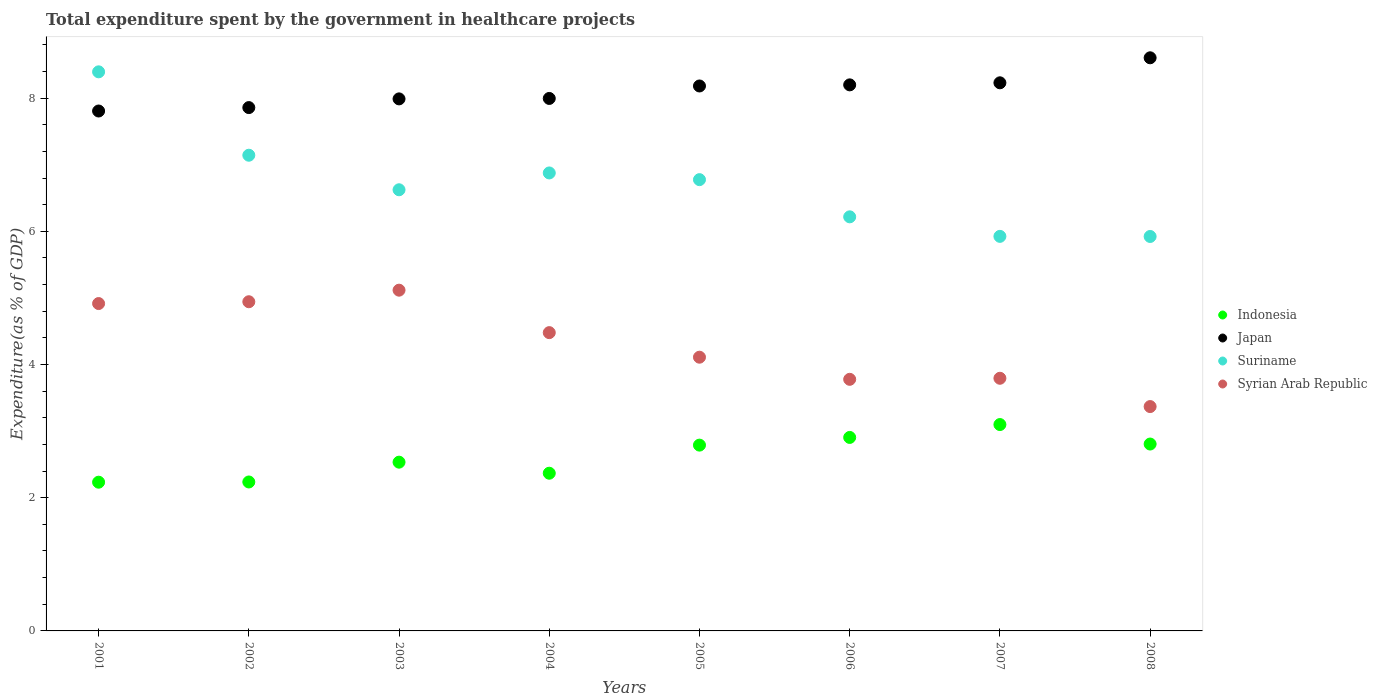What is the total expenditure spent by the government in healthcare projects in Syrian Arab Republic in 2007?
Your response must be concise. 3.79. Across all years, what is the maximum total expenditure spent by the government in healthcare projects in Suriname?
Your response must be concise. 8.39. Across all years, what is the minimum total expenditure spent by the government in healthcare projects in Suriname?
Provide a short and direct response. 5.92. In which year was the total expenditure spent by the government in healthcare projects in Syrian Arab Republic minimum?
Your answer should be compact. 2008. What is the total total expenditure spent by the government in healthcare projects in Syrian Arab Republic in the graph?
Offer a very short reply. 34.5. What is the difference between the total expenditure spent by the government in healthcare projects in Japan in 2001 and that in 2005?
Give a very brief answer. -0.38. What is the difference between the total expenditure spent by the government in healthcare projects in Indonesia in 2002 and the total expenditure spent by the government in healthcare projects in Japan in 2007?
Your response must be concise. -5.99. What is the average total expenditure spent by the government in healthcare projects in Suriname per year?
Offer a very short reply. 6.73. In the year 2004, what is the difference between the total expenditure spent by the government in healthcare projects in Syrian Arab Republic and total expenditure spent by the government in healthcare projects in Suriname?
Give a very brief answer. -2.4. In how many years, is the total expenditure spent by the government in healthcare projects in Indonesia greater than 5.6 %?
Your answer should be very brief. 0. What is the ratio of the total expenditure spent by the government in healthcare projects in Suriname in 2004 to that in 2007?
Keep it short and to the point. 1.16. What is the difference between the highest and the second highest total expenditure spent by the government in healthcare projects in Suriname?
Provide a succinct answer. 1.25. What is the difference between the highest and the lowest total expenditure spent by the government in healthcare projects in Japan?
Ensure brevity in your answer.  0.8. Is it the case that in every year, the sum of the total expenditure spent by the government in healthcare projects in Japan and total expenditure spent by the government in healthcare projects in Indonesia  is greater than the total expenditure spent by the government in healthcare projects in Suriname?
Offer a very short reply. Yes. Does the total expenditure spent by the government in healthcare projects in Syrian Arab Republic monotonically increase over the years?
Provide a succinct answer. No. How many years are there in the graph?
Offer a terse response. 8. Are the values on the major ticks of Y-axis written in scientific E-notation?
Make the answer very short. No. Does the graph contain grids?
Offer a terse response. No. Where does the legend appear in the graph?
Your answer should be very brief. Center right. How are the legend labels stacked?
Offer a terse response. Vertical. What is the title of the graph?
Your response must be concise. Total expenditure spent by the government in healthcare projects. Does "Kosovo" appear as one of the legend labels in the graph?
Offer a terse response. No. What is the label or title of the Y-axis?
Give a very brief answer. Expenditure(as % of GDP). What is the Expenditure(as % of GDP) of Indonesia in 2001?
Keep it short and to the point. 2.23. What is the Expenditure(as % of GDP) in Japan in 2001?
Offer a terse response. 7.81. What is the Expenditure(as % of GDP) in Suriname in 2001?
Offer a very short reply. 8.39. What is the Expenditure(as % of GDP) in Syrian Arab Republic in 2001?
Your answer should be compact. 4.92. What is the Expenditure(as % of GDP) in Indonesia in 2002?
Your response must be concise. 2.24. What is the Expenditure(as % of GDP) of Japan in 2002?
Your answer should be very brief. 7.86. What is the Expenditure(as % of GDP) of Suriname in 2002?
Your answer should be compact. 7.14. What is the Expenditure(as % of GDP) in Syrian Arab Republic in 2002?
Your answer should be compact. 4.94. What is the Expenditure(as % of GDP) in Indonesia in 2003?
Your answer should be compact. 2.53. What is the Expenditure(as % of GDP) of Japan in 2003?
Provide a succinct answer. 7.99. What is the Expenditure(as % of GDP) of Suriname in 2003?
Provide a succinct answer. 6.62. What is the Expenditure(as % of GDP) of Syrian Arab Republic in 2003?
Offer a very short reply. 5.12. What is the Expenditure(as % of GDP) in Indonesia in 2004?
Ensure brevity in your answer.  2.37. What is the Expenditure(as % of GDP) in Japan in 2004?
Give a very brief answer. 7.99. What is the Expenditure(as % of GDP) of Suriname in 2004?
Provide a short and direct response. 6.88. What is the Expenditure(as % of GDP) of Syrian Arab Republic in 2004?
Provide a short and direct response. 4.48. What is the Expenditure(as % of GDP) in Indonesia in 2005?
Ensure brevity in your answer.  2.79. What is the Expenditure(as % of GDP) of Japan in 2005?
Provide a succinct answer. 8.18. What is the Expenditure(as % of GDP) of Suriname in 2005?
Provide a short and direct response. 6.78. What is the Expenditure(as % of GDP) in Syrian Arab Republic in 2005?
Ensure brevity in your answer.  4.11. What is the Expenditure(as % of GDP) in Indonesia in 2006?
Provide a short and direct response. 2.91. What is the Expenditure(as % of GDP) in Japan in 2006?
Give a very brief answer. 8.2. What is the Expenditure(as % of GDP) in Suriname in 2006?
Make the answer very short. 6.22. What is the Expenditure(as % of GDP) in Syrian Arab Republic in 2006?
Make the answer very short. 3.78. What is the Expenditure(as % of GDP) of Indonesia in 2007?
Provide a short and direct response. 3.1. What is the Expenditure(as % of GDP) of Japan in 2007?
Offer a very short reply. 8.23. What is the Expenditure(as % of GDP) of Suriname in 2007?
Your answer should be very brief. 5.92. What is the Expenditure(as % of GDP) of Syrian Arab Republic in 2007?
Provide a short and direct response. 3.79. What is the Expenditure(as % of GDP) of Indonesia in 2008?
Offer a terse response. 2.81. What is the Expenditure(as % of GDP) of Japan in 2008?
Ensure brevity in your answer.  8.61. What is the Expenditure(as % of GDP) of Suriname in 2008?
Provide a succinct answer. 5.92. What is the Expenditure(as % of GDP) in Syrian Arab Republic in 2008?
Provide a short and direct response. 3.37. Across all years, what is the maximum Expenditure(as % of GDP) in Indonesia?
Offer a very short reply. 3.1. Across all years, what is the maximum Expenditure(as % of GDP) of Japan?
Give a very brief answer. 8.61. Across all years, what is the maximum Expenditure(as % of GDP) of Suriname?
Offer a terse response. 8.39. Across all years, what is the maximum Expenditure(as % of GDP) in Syrian Arab Republic?
Give a very brief answer. 5.12. Across all years, what is the minimum Expenditure(as % of GDP) in Indonesia?
Your response must be concise. 2.23. Across all years, what is the minimum Expenditure(as % of GDP) of Japan?
Provide a short and direct response. 7.81. Across all years, what is the minimum Expenditure(as % of GDP) in Suriname?
Make the answer very short. 5.92. Across all years, what is the minimum Expenditure(as % of GDP) of Syrian Arab Republic?
Ensure brevity in your answer.  3.37. What is the total Expenditure(as % of GDP) in Indonesia in the graph?
Offer a very short reply. 20.97. What is the total Expenditure(as % of GDP) in Japan in the graph?
Offer a very short reply. 64.86. What is the total Expenditure(as % of GDP) in Suriname in the graph?
Keep it short and to the point. 53.88. What is the total Expenditure(as % of GDP) of Syrian Arab Republic in the graph?
Your answer should be compact. 34.5. What is the difference between the Expenditure(as % of GDP) in Indonesia in 2001 and that in 2002?
Offer a very short reply. -0. What is the difference between the Expenditure(as % of GDP) in Japan in 2001 and that in 2002?
Give a very brief answer. -0.05. What is the difference between the Expenditure(as % of GDP) in Suriname in 2001 and that in 2002?
Keep it short and to the point. 1.25. What is the difference between the Expenditure(as % of GDP) in Syrian Arab Republic in 2001 and that in 2002?
Offer a terse response. -0.03. What is the difference between the Expenditure(as % of GDP) of Indonesia in 2001 and that in 2003?
Provide a succinct answer. -0.3. What is the difference between the Expenditure(as % of GDP) in Japan in 2001 and that in 2003?
Keep it short and to the point. -0.18. What is the difference between the Expenditure(as % of GDP) in Suriname in 2001 and that in 2003?
Give a very brief answer. 1.77. What is the difference between the Expenditure(as % of GDP) of Syrian Arab Republic in 2001 and that in 2003?
Make the answer very short. -0.2. What is the difference between the Expenditure(as % of GDP) of Indonesia in 2001 and that in 2004?
Provide a succinct answer. -0.13. What is the difference between the Expenditure(as % of GDP) of Japan in 2001 and that in 2004?
Give a very brief answer. -0.19. What is the difference between the Expenditure(as % of GDP) in Suriname in 2001 and that in 2004?
Your answer should be very brief. 1.52. What is the difference between the Expenditure(as % of GDP) of Syrian Arab Republic in 2001 and that in 2004?
Offer a very short reply. 0.44. What is the difference between the Expenditure(as % of GDP) in Indonesia in 2001 and that in 2005?
Your answer should be compact. -0.56. What is the difference between the Expenditure(as % of GDP) of Japan in 2001 and that in 2005?
Keep it short and to the point. -0.38. What is the difference between the Expenditure(as % of GDP) of Suriname in 2001 and that in 2005?
Give a very brief answer. 1.62. What is the difference between the Expenditure(as % of GDP) of Syrian Arab Republic in 2001 and that in 2005?
Make the answer very short. 0.81. What is the difference between the Expenditure(as % of GDP) in Indonesia in 2001 and that in 2006?
Your response must be concise. -0.67. What is the difference between the Expenditure(as % of GDP) of Japan in 2001 and that in 2006?
Make the answer very short. -0.39. What is the difference between the Expenditure(as % of GDP) in Suriname in 2001 and that in 2006?
Provide a succinct answer. 2.18. What is the difference between the Expenditure(as % of GDP) in Syrian Arab Republic in 2001 and that in 2006?
Offer a terse response. 1.14. What is the difference between the Expenditure(as % of GDP) in Indonesia in 2001 and that in 2007?
Make the answer very short. -0.87. What is the difference between the Expenditure(as % of GDP) of Japan in 2001 and that in 2007?
Keep it short and to the point. -0.42. What is the difference between the Expenditure(as % of GDP) in Suriname in 2001 and that in 2007?
Give a very brief answer. 2.47. What is the difference between the Expenditure(as % of GDP) in Syrian Arab Republic in 2001 and that in 2007?
Provide a succinct answer. 1.12. What is the difference between the Expenditure(as % of GDP) of Indonesia in 2001 and that in 2008?
Your answer should be compact. -0.57. What is the difference between the Expenditure(as % of GDP) of Japan in 2001 and that in 2008?
Your answer should be compact. -0.8. What is the difference between the Expenditure(as % of GDP) in Suriname in 2001 and that in 2008?
Your answer should be compact. 2.47. What is the difference between the Expenditure(as % of GDP) of Syrian Arab Republic in 2001 and that in 2008?
Ensure brevity in your answer.  1.55. What is the difference between the Expenditure(as % of GDP) in Indonesia in 2002 and that in 2003?
Give a very brief answer. -0.3. What is the difference between the Expenditure(as % of GDP) in Japan in 2002 and that in 2003?
Provide a succinct answer. -0.13. What is the difference between the Expenditure(as % of GDP) of Suriname in 2002 and that in 2003?
Keep it short and to the point. 0.52. What is the difference between the Expenditure(as % of GDP) in Syrian Arab Republic in 2002 and that in 2003?
Provide a short and direct response. -0.17. What is the difference between the Expenditure(as % of GDP) of Indonesia in 2002 and that in 2004?
Your response must be concise. -0.13. What is the difference between the Expenditure(as % of GDP) of Japan in 2002 and that in 2004?
Make the answer very short. -0.14. What is the difference between the Expenditure(as % of GDP) of Suriname in 2002 and that in 2004?
Your response must be concise. 0.27. What is the difference between the Expenditure(as % of GDP) in Syrian Arab Republic in 2002 and that in 2004?
Provide a short and direct response. 0.46. What is the difference between the Expenditure(as % of GDP) of Indonesia in 2002 and that in 2005?
Provide a short and direct response. -0.55. What is the difference between the Expenditure(as % of GDP) of Japan in 2002 and that in 2005?
Your answer should be compact. -0.32. What is the difference between the Expenditure(as % of GDP) of Suriname in 2002 and that in 2005?
Provide a short and direct response. 0.37. What is the difference between the Expenditure(as % of GDP) in Syrian Arab Republic in 2002 and that in 2005?
Provide a short and direct response. 0.83. What is the difference between the Expenditure(as % of GDP) of Indonesia in 2002 and that in 2006?
Your response must be concise. -0.67. What is the difference between the Expenditure(as % of GDP) of Japan in 2002 and that in 2006?
Give a very brief answer. -0.34. What is the difference between the Expenditure(as % of GDP) of Suriname in 2002 and that in 2006?
Your answer should be very brief. 0.92. What is the difference between the Expenditure(as % of GDP) of Syrian Arab Republic in 2002 and that in 2006?
Ensure brevity in your answer.  1.16. What is the difference between the Expenditure(as % of GDP) of Indonesia in 2002 and that in 2007?
Ensure brevity in your answer.  -0.86. What is the difference between the Expenditure(as % of GDP) of Japan in 2002 and that in 2007?
Make the answer very short. -0.37. What is the difference between the Expenditure(as % of GDP) in Suriname in 2002 and that in 2007?
Keep it short and to the point. 1.22. What is the difference between the Expenditure(as % of GDP) of Syrian Arab Republic in 2002 and that in 2007?
Offer a terse response. 1.15. What is the difference between the Expenditure(as % of GDP) in Indonesia in 2002 and that in 2008?
Offer a very short reply. -0.57. What is the difference between the Expenditure(as % of GDP) in Japan in 2002 and that in 2008?
Ensure brevity in your answer.  -0.75. What is the difference between the Expenditure(as % of GDP) in Suriname in 2002 and that in 2008?
Your answer should be compact. 1.22. What is the difference between the Expenditure(as % of GDP) of Syrian Arab Republic in 2002 and that in 2008?
Your answer should be compact. 1.57. What is the difference between the Expenditure(as % of GDP) in Indonesia in 2003 and that in 2004?
Offer a terse response. 0.17. What is the difference between the Expenditure(as % of GDP) in Japan in 2003 and that in 2004?
Ensure brevity in your answer.  -0.01. What is the difference between the Expenditure(as % of GDP) in Suriname in 2003 and that in 2004?
Ensure brevity in your answer.  -0.25. What is the difference between the Expenditure(as % of GDP) in Syrian Arab Republic in 2003 and that in 2004?
Offer a terse response. 0.64. What is the difference between the Expenditure(as % of GDP) in Indonesia in 2003 and that in 2005?
Keep it short and to the point. -0.26. What is the difference between the Expenditure(as % of GDP) of Japan in 2003 and that in 2005?
Keep it short and to the point. -0.19. What is the difference between the Expenditure(as % of GDP) of Suriname in 2003 and that in 2005?
Ensure brevity in your answer.  -0.15. What is the difference between the Expenditure(as % of GDP) of Syrian Arab Republic in 2003 and that in 2005?
Make the answer very short. 1.01. What is the difference between the Expenditure(as % of GDP) of Indonesia in 2003 and that in 2006?
Provide a short and direct response. -0.37. What is the difference between the Expenditure(as % of GDP) in Japan in 2003 and that in 2006?
Offer a terse response. -0.21. What is the difference between the Expenditure(as % of GDP) in Suriname in 2003 and that in 2006?
Offer a terse response. 0.41. What is the difference between the Expenditure(as % of GDP) in Syrian Arab Republic in 2003 and that in 2006?
Provide a short and direct response. 1.34. What is the difference between the Expenditure(as % of GDP) in Indonesia in 2003 and that in 2007?
Keep it short and to the point. -0.56. What is the difference between the Expenditure(as % of GDP) of Japan in 2003 and that in 2007?
Your response must be concise. -0.24. What is the difference between the Expenditure(as % of GDP) in Suriname in 2003 and that in 2007?
Offer a very short reply. 0.7. What is the difference between the Expenditure(as % of GDP) in Syrian Arab Republic in 2003 and that in 2007?
Provide a short and direct response. 1.32. What is the difference between the Expenditure(as % of GDP) of Indonesia in 2003 and that in 2008?
Ensure brevity in your answer.  -0.27. What is the difference between the Expenditure(as % of GDP) in Japan in 2003 and that in 2008?
Your answer should be compact. -0.62. What is the difference between the Expenditure(as % of GDP) of Suriname in 2003 and that in 2008?
Provide a short and direct response. 0.7. What is the difference between the Expenditure(as % of GDP) in Syrian Arab Republic in 2003 and that in 2008?
Provide a short and direct response. 1.75. What is the difference between the Expenditure(as % of GDP) in Indonesia in 2004 and that in 2005?
Make the answer very short. -0.42. What is the difference between the Expenditure(as % of GDP) in Japan in 2004 and that in 2005?
Your response must be concise. -0.19. What is the difference between the Expenditure(as % of GDP) of Suriname in 2004 and that in 2005?
Offer a very short reply. 0.1. What is the difference between the Expenditure(as % of GDP) of Syrian Arab Republic in 2004 and that in 2005?
Provide a short and direct response. 0.37. What is the difference between the Expenditure(as % of GDP) of Indonesia in 2004 and that in 2006?
Make the answer very short. -0.54. What is the difference between the Expenditure(as % of GDP) in Japan in 2004 and that in 2006?
Keep it short and to the point. -0.2. What is the difference between the Expenditure(as % of GDP) in Suriname in 2004 and that in 2006?
Provide a short and direct response. 0.66. What is the difference between the Expenditure(as % of GDP) in Syrian Arab Republic in 2004 and that in 2006?
Give a very brief answer. 0.7. What is the difference between the Expenditure(as % of GDP) of Indonesia in 2004 and that in 2007?
Ensure brevity in your answer.  -0.73. What is the difference between the Expenditure(as % of GDP) of Japan in 2004 and that in 2007?
Provide a succinct answer. -0.23. What is the difference between the Expenditure(as % of GDP) in Suriname in 2004 and that in 2007?
Make the answer very short. 0.95. What is the difference between the Expenditure(as % of GDP) of Syrian Arab Republic in 2004 and that in 2007?
Provide a succinct answer. 0.69. What is the difference between the Expenditure(as % of GDP) in Indonesia in 2004 and that in 2008?
Give a very brief answer. -0.44. What is the difference between the Expenditure(as % of GDP) of Japan in 2004 and that in 2008?
Ensure brevity in your answer.  -0.61. What is the difference between the Expenditure(as % of GDP) of Suriname in 2004 and that in 2008?
Provide a short and direct response. 0.95. What is the difference between the Expenditure(as % of GDP) of Syrian Arab Republic in 2004 and that in 2008?
Provide a succinct answer. 1.11. What is the difference between the Expenditure(as % of GDP) of Indonesia in 2005 and that in 2006?
Your answer should be compact. -0.12. What is the difference between the Expenditure(as % of GDP) of Japan in 2005 and that in 2006?
Offer a very short reply. -0.02. What is the difference between the Expenditure(as % of GDP) of Suriname in 2005 and that in 2006?
Your response must be concise. 0.56. What is the difference between the Expenditure(as % of GDP) of Syrian Arab Republic in 2005 and that in 2006?
Your answer should be very brief. 0.33. What is the difference between the Expenditure(as % of GDP) in Indonesia in 2005 and that in 2007?
Ensure brevity in your answer.  -0.31. What is the difference between the Expenditure(as % of GDP) of Japan in 2005 and that in 2007?
Your answer should be very brief. -0.05. What is the difference between the Expenditure(as % of GDP) of Suriname in 2005 and that in 2007?
Offer a very short reply. 0.85. What is the difference between the Expenditure(as % of GDP) of Syrian Arab Republic in 2005 and that in 2007?
Provide a succinct answer. 0.32. What is the difference between the Expenditure(as % of GDP) in Indonesia in 2005 and that in 2008?
Your answer should be very brief. -0.02. What is the difference between the Expenditure(as % of GDP) in Japan in 2005 and that in 2008?
Offer a very short reply. -0.42. What is the difference between the Expenditure(as % of GDP) of Suriname in 2005 and that in 2008?
Give a very brief answer. 0.85. What is the difference between the Expenditure(as % of GDP) in Syrian Arab Republic in 2005 and that in 2008?
Your response must be concise. 0.74. What is the difference between the Expenditure(as % of GDP) in Indonesia in 2006 and that in 2007?
Offer a terse response. -0.19. What is the difference between the Expenditure(as % of GDP) of Japan in 2006 and that in 2007?
Your answer should be very brief. -0.03. What is the difference between the Expenditure(as % of GDP) of Suriname in 2006 and that in 2007?
Your answer should be very brief. 0.29. What is the difference between the Expenditure(as % of GDP) in Syrian Arab Republic in 2006 and that in 2007?
Your answer should be very brief. -0.02. What is the difference between the Expenditure(as % of GDP) of Indonesia in 2006 and that in 2008?
Make the answer very short. 0.1. What is the difference between the Expenditure(as % of GDP) in Japan in 2006 and that in 2008?
Ensure brevity in your answer.  -0.41. What is the difference between the Expenditure(as % of GDP) in Suriname in 2006 and that in 2008?
Offer a terse response. 0.29. What is the difference between the Expenditure(as % of GDP) of Syrian Arab Republic in 2006 and that in 2008?
Provide a succinct answer. 0.41. What is the difference between the Expenditure(as % of GDP) of Indonesia in 2007 and that in 2008?
Make the answer very short. 0.29. What is the difference between the Expenditure(as % of GDP) of Japan in 2007 and that in 2008?
Provide a short and direct response. -0.38. What is the difference between the Expenditure(as % of GDP) in Suriname in 2007 and that in 2008?
Your answer should be compact. 0. What is the difference between the Expenditure(as % of GDP) of Syrian Arab Republic in 2007 and that in 2008?
Offer a terse response. 0.42. What is the difference between the Expenditure(as % of GDP) of Indonesia in 2001 and the Expenditure(as % of GDP) of Japan in 2002?
Keep it short and to the point. -5.62. What is the difference between the Expenditure(as % of GDP) in Indonesia in 2001 and the Expenditure(as % of GDP) in Suriname in 2002?
Give a very brief answer. -4.91. What is the difference between the Expenditure(as % of GDP) in Indonesia in 2001 and the Expenditure(as % of GDP) in Syrian Arab Republic in 2002?
Offer a terse response. -2.71. What is the difference between the Expenditure(as % of GDP) of Japan in 2001 and the Expenditure(as % of GDP) of Suriname in 2002?
Make the answer very short. 0.66. What is the difference between the Expenditure(as % of GDP) in Japan in 2001 and the Expenditure(as % of GDP) in Syrian Arab Republic in 2002?
Offer a terse response. 2.86. What is the difference between the Expenditure(as % of GDP) in Suriname in 2001 and the Expenditure(as % of GDP) in Syrian Arab Republic in 2002?
Provide a short and direct response. 3.45. What is the difference between the Expenditure(as % of GDP) of Indonesia in 2001 and the Expenditure(as % of GDP) of Japan in 2003?
Ensure brevity in your answer.  -5.75. What is the difference between the Expenditure(as % of GDP) in Indonesia in 2001 and the Expenditure(as % of GDP) in Suriname in 2003?
Provide a succinct answer. -4.39. What is the difference between the Expenditure(as % of GDP) of Indonesia in 2001 and the Expenditure(as % of GDP) of Syrian Arab Republic in 2003?
Make the answer very short. -2.88. What is the difference between the Expenditure(as % of GDP) in Japan in 2001 and the Expenditure(as % of GDP) in Suriname in 2003?
Offer a very short reply. 1.18. What is the difference between the Expenditure(as % of GDP) of Japan in 2001 and the Expenditure(as % of GDP) of Syrian Arab Republic in 2003?
Keep it short and to the point. 2.69. What is the difference between the Expenditure(as % of GDP) in Suriname in 2001 and the Expenditure(as % of GDP) in Syrian Arab Republic in 2003?
Offer a very short reply. 3.28. What is the difference between the Expenditure(as % of GDP) in Indonesia in 2001 and the Expenditure(as % of GDP) in Japan in 2004?
Your answer should be very brief. -5.76. What is the difference between the Expenditure(as % of GDP) in Indonesia in 2001 and the Expenditure(as % of GDP) in Suriname in 2004?
Offer a terse response. -4.64. What is the difference between the Expenditure(as % of GDP) of Indonesia in 2001 and the Expenditure(as % of GDP) of Syrian Arab Republic in 2004?
Keep it short and to the point. -2.25. What is the difference between the Expenditure(as % of GDP) in Japan in 2001 and the Expenditure(as % of GDP) in Suriname in 2004?
Give a very brief answer. 0.93. What is the difference between the Expenditure(as % of GDP) of Japan in 2001 and the Expenditure(as % of GDP) of Syrian Arab Republic in 2004?
Your response must be concise. 3.33. What is the difference between the Expenditure(as % of GDP) of Suriname in 2001 and the Expenditure(as % of GDP) of Syrian Arab Republic in 2004?
Offer a terse response. 3.92. What is the difference between the Expenditure(as % of GDP) of Indonesia in 2001 and the Expenditure(as % of GDP) of Japan in 2005?
Offer a terse response. -5.95. What is the difference between the Expenditure(as % of GDP) of Indonesia in 2001 and the Expenditure(as % of GDP) of Suriname in 2005?
Offer a terse response. -4.54. What is the difference between the Expenditure(as % of GDP) in Indonesia in 2001 and the Expenditure(as % of GDP) in Syrian Arab Republic in 2005?
Provide a succinct answer. -1.88. What is the difference between the Expenditure(as % of GDP) of Japan in 2001 and the Expenditure(as % of GDP) of Suriname in 2005?
Offer a terse response. 1.03. What is the difference between the Expenditure(as % of GDP) of Japan in 2001 and the Expenditure(as % of GDP) of Syrian Arab Republic in 2005?
Your answer should be compact. 3.7. What is the difference between the Expenditure(as % of GDP) in Suriname in 2001 and the Expenditure(as % of GDP) in Syrian Arab Republic in 2005?
Your answer should be compact. 4.28. What is the difference between the Expenditure(as % of GDP) of Indonesia in 2001 and the Expenditure(as % of GDP) of Japan in 2006?
Provide a succinct answer. -5.97. What is the difference between the Expenditure(as % of GDP) in Indonesia in 2001 and the Expenditure(as % of GDP) in Suriname in 2006?
Offer a terse response. -3.98. What is the difference between the Expenditure(as % of GDP) in Indonesia in 2001 and the Expenditure(as % of GDP) in Syrian Arab Republic in 2006?
Ensure brevity in your answer.  -1.54. What is the difference between the Expenditure(as % of GDP) in Japan in 2001 and the Expenditure(as % of GDP) in Suriname in 2006?
Offer a terse response. 1.59. What is the difference between the Expenditure(as % of GDP) of Japan in 2001 and the Expenditure(as % of GDP) of Syrian Arab Republic in 2006?
Make the answer very short. 4.03. What is the difference between the Expenditure(as % of GDP) of Suriname in 2001 and the Expenditure(as % of GDP) of Syrian Arab Republic in 2006?
Your answer should be very brief. 4.62. What is the difference between the Expenditure(as % of GDP) in Indonesia in 2001 and the Expenditure(as % of GDP) in Japan in 2007?
Your answer should be compact. -6. What is the difference between the Expenditure(as % of GDP) of Indonesia in 2001 and the Expenditure(as % of GDP) of Suriname in 2007?
Keep it short and to the point. -3.69. What is the difference between the Expenditure(as % of GDP) of Indonesia in 2001 and the Expenditure(as % of GDP) of Syrian Arab Republic in 2007?
Keep it short and to the point. -1.56. What is the difference between the Expenditure(as % of GDP) of Japan in 2001 and the Expenditure(as % of GDP) of Suriname in 2007?
Offer a terse response. 1.88. What is the difference between the Expenditure(as % of GDP) in Japan in 2001 and the Expenditure(as % of GDP) in Syrian Arab Republic in 2007?
Offer a terse response. 4.01. What is the difference between the Expenditure(as % of GDP) in Suriname in 2001 and the Expenditure(as % of GDP) in Syrian Arab Republic in 2007?
Make the answer very short. 4.6. What is the difference between the Expenditure(as % of GDP) in Indonesia in 2001 and the Expenditure(as % of GDP) in Japan in 2008?
Provide a succinct answer. -6.37. What is the difference between the Expenditure(as % of GDP) in Indonesia in 2001 and the Expenditure(as % of GDP) in Suriname in 2008?
Your response must be concise. -3.69. What is the difference between the Expenditure(as % of GDP) in Indonesia in 2001 and the Expenditure(as % of GDP) in Syrian Arab Republic in 2008?
Your answer should be very brief. -1.14. What is the difference between the Expenditure(as % of GDP) of Japan in 2001 and the Expenditure(as % of GDP) of Suriname in 2008?
Provide a short and direct response. 1.88. What is the difference between the Expenditure(as % of GDP) of Japan in 2001 and the Expenditure(as % of GDP) of Syrian Arab Republic in 2008?
Offer a terse response. 4.44. What is the difference between the Expenditure(as % of GDP) in Suriname in 2001 and the Expenditure(as % of GDP) in Syrian Arab Republic in 2008?
Give a very brief answer. 5.03. What is the difference between the Expenditure(as % of GDP) in Indonesia in 2002 and the Expenditure(as % of GDP) in Japan in 2003?
Offer a very short reply. -5.75. What is the difference between the Expenditure(as % of GDP) in Indonesia in 2002 and the Expenditure(as % of GDP) in Suriname in 2003?
Your answer should be compact. -4.39. What is the difference between the Expenditure(as % of GDP) of Indonesia in 2002 and the Expenditure(as % of GDP) of Syrian Arab Republic in 2003?
Make the answer very short. -2.88. What is the difference between the Expenditure(as % of GDP) in Japan in 2002 and the Expenditure(as % of GDP) in Suriname in 2003?
Offer a terse response. 1.23. What is the difference between the Expenditure(as % of GDP) of Japan in 2002 and the Expenditure(as % of GDP) of Syrian Arab Republic in 2003?
Your answer should be compact. 2.74. What is the difference between the Expenditure(as % of GDP) of Suriname in 2002 and the Expenditure(as % of GDP) of Syrian Arab Republic in 2003?
Give a very brief answer. 2.03. What is the difference between the Expenditure(as % of GDP) in Indonesia in 2002 and the Expenditure(as % of GDP) in Japan in 2004?
Offer a very short reply. -5.76. What is the difference between the Expenditure(as % of GDP) in Indonesia in 2002 and the Expenditure(as % of GDP) in Suriname in 2004?
Provide a succinct answer. -4.64. What is the difference between the Expenditure(as % of GDP) of Indonesia in 2002 and the Expenditure(as % of GDP) of Syrian Arab Republic in 2004?
Your response must be concise. -2.24. What is the difference between the Expenditure(as % of GDP) of Japan in 2002 and the Expenditure(as % of GDP) of Suriname in 2004?
Offer a terse response. 0.98. What is the difference between the Expenditure(as % of GDP) in Japan in 2002 and the Expenditure(as % of GDP) in Syrian Arab Republic in 2004?
Your answer should be compact. 3.38. What is the difference between the Expenditure(as % of GDP) in Suriname in 2002 and the Expenditure(as % of GDP) in Syrian Arab Republic in 2004?
Your response must be concise. 2.66. What is the difference between the Expenditure(as % of GDP) of Indonesia in 2002 and the Expenditure(as % of GDP) of Japan in 2005?
Your answer should be very brief. -5.95. What is the difference between the Expenditure(as % of GDP) of Indonesia in 2002 and the Expenditure(as % of GDP) of Suriname in 2005?
Give a very brief answer. -4.54. What is the difference between the Expenditure(as % of GDP) of Indonesia in 2002 and the Expenditure(as % of GDP) of Syrian Arab Republic in 2005?
Give a very brief answer. -1.87. What is the difference between the Expenditure(as % of GDP) in Japan in 2002 and the Expenditure(as % of GDP) in Suriname in 2005?
Offer a terse response. 1.08. What is the difference between the Expenditure(as % of GDP) of Japan in 2002 and the Expenditure(as % of GDP) of Syrian Arab Republic in 2005?
Ensure brevity in your answer.  3.75. What is the difference between the Expenditure(as % of GDP) in Suriname in 2002 and the Expenditure(as % of GDP) in Syrian Arab Republic in 2005?
Your answer should be compact. 3.03. What is the difference between the Expenditure(as % of GDP) of Indonesia in 2002 and the Expenditure(as % of GDP) of Japan in 2006?
Ensure brevity in your answer.  -5.96. What is the difference between the Expenditure(as % of GDP) of Indonesia in 2002 and the Expenditure(as % of GDP) of Suriname in 2006?
Make the answer very short. -3.98. What is the difference between the Expenditure(as % of GDP) in Indonesia in 2002 and the Expenditure(as % of GDP) in Syrian Arab Republic in 2006?
Make the answer very short. -1.54. What is the difference between the Expenditure(as % of GDP) of Japan in 2002 and the Expenditure(as % of GDP) of Suriname in 2006?
Provide a succinct answer. 1.64. What is the difference between the Expenditure(as % of GDP) of Japan in 2002 and the Expenditure(as % of GDP) of Syrian Arab Republic in 2006?
Your answer should be very brief. 4.08. What is the difference between the Expenditure(as % of GDP) in Suriname in 2002 and the Expenditure(as % of GDP) in Syrian Arab Republic in 2006?
Provide a succinct answer. 3.36. What is the difference between the Expenditure(as % of GDP) in Indonesia in 2002 and the Expenditure(as % of GDP) in Japan in 2007?
Provide a succinct answer. -5.99. What is the difference between the Expenditure(as % of GDP) in Indonesia in 2002 and the Expenditure(as % of GDP) in Suriname in 2007?
Provide a short and direct response. -3.69. What is the difference between the Expenditure(as % of GDP) in Indonesia in 2002 and the Expenditure(as % of GDP) in Syrian Arab Republic in 2007?
Your answer should be very brief. -1.56. What is the difference between the Expenditure(as % of GDP) of Japan in 2002 and the Expenditure(as % of GDP) of Suriname in 2007?
Keep it short and to the point. 1.93. What is the difference between the Expenditure(as % of GDP) in Japan in 2002 and the Expenditure(as % of GDP) in Syrian Arab Republic in 2007?
Provide a short and direct response. 4.06. What is the difference between the Expenditure(as % of GDP) of Suriname in 2002 and the Expenditure(as % of GDP) of Syrian Arab Republic in 2007?
Give a very brief answer. 3.35. What is the difference between the Expenditure(as % of GDP) in Indonesia in 2002 and the Expenditure(as % of GDP) in Japan in 2008?
Provide a succinct answer. -6.37. What is the difference between the Expenditure(as % of GDP) of Indonesia in 2002 and the Expenditure(as % of GDP) of Suriname in 2008?
Provide a succinct answer. -3.69. What is the difference between the Expenditure(as % of GDP) in Indonesia in 2002 and the Expenditure(as % of GDP) in Syrian Arab Republic in 2008?
Your answer should be compact. -1.13. What is the difference between the Expenditure(as % of GDP) of Japan in 2002 and the Expenditure(as % of GDP) of Suriname in 2008?
Make the answer very short. 1.94. What is the difference between the Expenditure(as % of GDP) in Japan in 2002 and the Expenditure(as % of GDP) in Syrian Arab Republic in 2008?
Give a very brief answer. 4.49. What is the difference between the Expenditure(as % of GDP) of Suriname in 2002 and the Expenditure(as % of GDP) of Syrian Arab Republic in 2008?
Your response must be concise. 3.77. What is the difference between the Expenditure(as % of GDP) in Indonesia in 2003 and the Expenditure(as % of GDP) in Japan in 2004?
Your response must be concise. -5.46. What is the difference between the Expenditure(as % of GDP) in Indonesia in 2003 and the Expenditure(as % of GDP) in Suriname in 2004?
Keep it short and to the point. -4.34. What is the difference between the Expenditure(as % of GDP) in Indonesia in 2003 and the Expenditure(as % of GDP) in Syrian Arab Republic in 2004?
Your response must be concise. -1.94. What is the difference between the Expenditure(as % of GDP) in Japan in 2003 and the Expenditure(as % of GDP) in Suriname in 2004?
Provide a short and direct response. 1.11. What is the difference between the Expenditure(as % of GDP) of Japan in 2003 and the Expenditure(as % of GDP) of Syrian Arab Republic in 2004?
Your answer should be very brief. 3.51. What is the difference between the Expenditure(as % of GDP) of Suriname in 2003 and the Expenditure(as % of GDP) of Syrian Arab Republic in 2004?
Provide a short and direct response. 2.14. What is the difference between the Expenditure(as % of GDP) of Indonesia in 2003 and the Expenditure(as % of GDP) of Japan in 2005?
Give a very brief answer. -5.65. What is the difference between the Expenditure(as % of GDP) of Indonesia in 2003 and the Expenditure(as % of GDP) of Suriname in 2005?
Ensure brevity in your answer.  -4.24. What is the difference between the Expenditure(as % of GDP) in Indonesia in 2003 and the Expenditure(as % of GDP) in Syrian Arab Republic in 2005?
Your answer should be compact. -1.58. What is the difference between the Expenditure(as % of GDP) in Japan in 2003 and the Expenditure(as % of GDP) in Suriname in 2005?
Your response must be concise. 1.21. What is the difference between the Expenditure(as % of GDP) of Japan in 2003 and the Expenditure(as % of GDP) of Syrian Arab Republic in 2005?
Your answer should be very brief. 3.88. What is the difference between the Expenditure(as % of GDP) in Suriname in 2003 and the Expenditure(as % of GDP) in Syrian Arab Republic in 2005?
Give a very brief answer. 2.51. What is the difference between the Expenditure(as % of GDP) in Indonesia in 2003 and the Expenditure(as % of GDP) in Japan in 2006?
Provide a short and direct response. -5.66. What is the difference between the Expenditure(as % of GDP) in Indonesia in 2003 and the Expenditure(as % of GDP) in Suriname in 2006?
Make the answer very short. -3.68. What is the difference between the Expenditure(as % of GDP) of Indonesia in 2003 and the Expenditure(as % of GDP) of Syrian Arab Republic in 2006?
Give a very brief answer. -1.24. What is the difference between the Expenditure(as % of GDP) of Japan in 2003 and the Expenditure(as % of GDP) of Suriname in 2006?
Provide a succinct answer. 1.77. What is the difference between the Expenditure(as % of GDP) of Japan in 2003 and the Expenditure(as % of GDP) of Syrian Arab Republic in 2006?
Ensure brevity in your answer.  4.21. What is the difference between the Expenditure(as % of GDP) in Suriname in 2003 and the Expenditure(as % of GDP) in Syrian Arab Republic in 2006?
Offer a very short reply. 2.85. What is the difference between the Expenditure(as % of GDP) of Indonesia in 2003 and the Expenditure(as % of GDP) of Japan in 2007?
Keep it short and to the point. -5.7. What is the difference between the Expenditure(as % of GDP) of Indonesia in 2003 and the Expenditure(as % of GDP) of Suriname in 2007?
Provide a short and direct response. -3.39. What is the difference between the Expenditure(as % of GDP) in Indonesia in 2003 and the Expenditure(as % of GDP) in Syrian Arab Republic in 2007?
Provide a short and direct response. -1.26. What is the difference between the Expenditure(as % of GDP) of Japan in 2003 and the Expenditure(as % of GDP) of Suriname in 2007?
Make the answer very short. 2.06. What is the difference between the Expenditure(as % of GDP) of Japan in 2003 and the Expenditure(as % of GDP) of Syrian Arab Republic in 2007?
Offer a very short reply. 4.19. What is the difference between the Expenditure(as % of GDP) of Suriname in 2003 and the Expenditure(as % of GDP) of Syrian Arab Republic in 2007?
Your answer should be compact. 2.83. What is the difference between the Expenditure(as % of GDP) of Indonesia in 2003 and the Expenditure(as % of GDP) of Japan in 2008?
Your answer should be very brief. -6.07. What is the difference between the Expenditure(as % of GDP) in Indonesia in 2003 and the Expenditure(as % of GDP) in Suriname in 2008?
Offer a very short reply. -3.39. What is the difference between the Expenditure(as % of GDP) of Indonesia in 2003 and the Expenditure(as % of GDP) of Syrian Arab Republic in 2008?
Your answer should be compact. -0.83. What is the difference between the Expenditure(as % of GDP) in Japan in 2003 and the Expenditure(as % of GDP) in Suriname in 2008?
Ensure brevity in your answer.  2.07. What is the difference between the Expenditure(as % of GDP) of Japan in 2003 and the Expenditure(as % of GDP) of Syrian Arab Republic in 2008?
Ensure brevity in your answer.  4.62. What is the difference between the Expenditure(as % of GDP) in Suriname in 2003 and the Expenditure(as % of GDP) in Syrian Arab Republic in 2008?
Offer a terse response. 3.26. What is the difference between the Expenditure(as % of GDP) of Indonesia in 2004 and the Expenditure(as % of GDP) of Japan in 2005?
Make the answer very short. -5.81. What is the difference between the Expenditure(as % of GDP) in Indonesia in 2004 and the Expenditure(as % of GDP) in Suriname in 2005?
Your answer should be very brief. -4.41. What is the difference between the Expenditure(as % of GDP) in Indonesia in 2004 and the Expenditure(as % of GDP) in Syrian Arab Republic in 2005?
Keep it short and to the point. -1.74. What is the difference between the Expenditure(as % of GDP) of Japan in 2004 and the Expenditure(as % of GDP) of Suriname in 2005?
Give a very brief answer. 1.22. What is the difference between the Expenditure(as % of GDP) in Japan in 2004 and the Expenditure(as % of GDP) in Syrian Arab Republic in 2005?
Give a very brief answer. 3.88. What is the difference between the Expenditure(as % of GDP) in Suriname in 2004 and the Expenditure(as % of GDP) in Syrian Arab Republic in 2005?
Your answer should be compact. 2.77. What is the difference between the Expenditure(as % of GDP) in Indonesia in 2004 and the Expenditure(as % of GDP) in Japan in 2006?
Your answer should be compact. -5.83. What is the difference between the Expenditure(as % of GDP) of Indonesia in 2004 and the Expenditure(as % of GDP) of Suriname in 2006?
Your answer should be very brief. -3.85. What is the difference between the Expenditure(as % of GDP) in Indonesia in 2004 and the Expenditure(as % of GDP) in Syrian Arab Republic in 2006?
Make the answer very short. -1.41. What is the difference between the Expenditure(as % of GDP) in Japan in 2004 and the Expenditure(as % of GDP) in Suriname in 2006?
Offer a terse response. 1.78. What is the difference between the Expenditure(as % of GDP) of Japan in 2004 and the Expenditure(as % of GDP) of Syrian Arab Republic in 2006?
Give a very brief answer. 4.22. What is the difference between the Expenditure(as % of GDP) of Suriname in 2004 and the Expenditure(as % of GDP) of Syrian Arab Republic in 2006?
Your answer should be compact. 3.1. What is the difference between the Expenditure(as % of GDP) of Indonesia in 2004 and the Expenditure(as % of GDP) of Japan in 2007?
Give a very brief answer. -5.86. What is the difference between the Expenditure(as % of GDP) of Indonesia in 2004 and the Expenditure(as % of GDP) of Suriname in 2007?
Keep it short and to the point. -3.56. What is the difference between the Expenditure(as % of GDP) in Indonesia in 2004 and the Expenditure(as % of GDP) in Syrian Arab Republic in 2007?
Offer a terse response. -1.43. What is the difference between the Expenditure(as % of GDP) of Japan in 2004 and the Expenditure(as % of GDP) of Suriname in 2007?
Make the answer very short. 2.07. What is the difference between the Expenditure(as % of GDP) in Japan in 2004 and the Expenditure(as % of GDP) in Syrian Arab Republic in 2007?
Keep it short and to the point. 4.2. What is the difference between the Expenditure(as % of GDP) in Suriname in 2004 and the Expenditure(as % of GDP) in Syrian Arab Republic in 2007?
Offer a terse response. 3.08. What is the difference between the Expenditure(as % of GDP) in Indonesia in 2004 and the Expenditure(as % of GDP) in Japan in 2008?
Offer a terse response. -6.24. What is the difference between the Expenditure(as % of GDP) in Indonesia in 2004 and the Expenditure(as % of GDP) in Suriname in 2008?
Your answer should be compact. -3.55. What is the difference between the Expenditure(as % of GDP) of Indonesia in 2004 and the Expenditure(as % of GDP) of Syrian Arab Republic in 2008?
Offer a very short reply. -1. What is the difference between the Expenditure(as % of GDP) of Japan in 2004 and the Expenditure(as % of GDP) of Suriname in 2008?
Give a very brief answer. 2.07. What is the difference between the Expenditure(as % of GDP) of Japan in 2004 and the Expenditure(as % of GDP) of Syrian Arab Republic in 2008?
Provide a short and direct response. 4.63. What is the difference between the Expenditure(as % of GDP) in Suriname in 2004 and the Expenditure(as % of GDP) in Syrian Arab Republic in 2008?
Provide a succinct answer. 3.51. What is the difference between the Expenditure(as % of GDP) in Indonesia in 2005 and the Expenditure(as % of GDP) in Japan in 2006?
Make the answer very short. -5.41. What is the difference between the Expenditure(as % of GDP) of Indonesia in 2005 and the Expenditure(as % of GDP) of Suriname in 2006?
Offer a terse response. -3.43. What is the difference between the Expenditure(as % of GDP) in Indonesia in 2005 and the Expenditure(as % of GDP) in Syrian Arab Republic in 2006?
Your answer should be very brief. -0.99. What is the difference between the Expenditure(as % of GDP) of Japan in 2005 and the Expenditure(as % of GDP) of Suriname in 2006?
Keep it short and to the point. 1.96. What is the difference between the Expenditure(as % of GDP) of Japan in 2005 and the Expenditure(as % of GDP) of Syrian Arab Republic in 2006?
Offer a very short reply. 4.4. What is the difference between the Expenditure(as % of GDP) of Suriname in 2005 and the Expenditure(as % of GDP) of Syrian Arab Republic in 2006?
Provide a short and direct response. 3. What is the difference between the Expenditure(as % of GDP) in Indonesia in 2005 and the Expenditure(as % of GDP) in Japan in 2007?
Provide a succinct answer. -5.44. What is the difference between the Expenditure(as % of GDP) in Indonesia in 2005 and the Expenditure(as % of GDP) in Suriname in 2007?
Offer a terse response. -3.13. What is the difference between the Expenditure(as % of GDP) in Indonesia in 2005 and the Expenditure(as % of GDP) in Syrian Arab Republic in 2007?
Your response must be concise. -1. What is the difference between the Expenditure(as % of GDP) in Japan in 2005 and the Expenditure(as % of GDP) in Suriname in 2007?
Offer a terse response. 2.26. What is the difference between the Expenditure(as % of GDP) in Japan in 2005 and the Expenditure(as % of GDP) in Syrian Arab Republic in 2007?
Provide a succinct answer. 4.39. What is the difference between the Expenditure(as % of GDP) in Suriname in 2005 and the Expenditure(as % of GDP) in Syrian Arab Republic in 2007?
Offer a very short reply. 2.98. What is the difference between the Expenditure(as % of GDP) of Indonesia in 2005 and the Expenditure(as % of GDP) of Japan in 2008?
Your response must be concise. -5.82. What is the difference between the Expenditure(as % of GDP) in Indonesia in 2005 and the Expenditure(as % of GDP) in Suriname in 2008?
Provide a short and direct response. -3.13. What is the difference between the Expenditure(as % of GDP) in Indonesia in 2005 and the Expenditure(as % of GDP) in Syrian Arab Republic in 2008?
Ensure brevity in your answer.  -0.58. What is the difference between the Expenditure(as % of GDP) in Japan in 2005 and the Expenditure(as % of GDP) in Suriname in 2008?
Provide a succinct answer. 2.26. What is the difference between the Expenditure(as % of GDP) in Japan in 2005 and the Expenditure(as % of GDP) in Syrian Arab Republic in 2008?
Your answer should be compact. 4.81. What is the difference between the Expenditure(as % of GDP) of Suriname in 2005 and the Expenditure(as % of GDP) of Syrian Arab Republic in 2008?
Ensure brevity in your answer.  3.41. What is the difference between the Expenditure(as % of GDP) of Indonesia in 2006 and the Expenditure(as % of GDP) of Japan in 2007?
Offer a very short reply. -5.32. What is the difference between the Expenditure(as % of GDP) of Indonesia in 2006 and the Expenditure(as % of GDP) of Suriname in 2007?
Offer a very short reply. -3.02. What is the difference between the Expenditure(as % of GDP) in Indonesia in 2006 and the Expenditure(as % of GDP) in Syrian Arab Republic in 2007?
Your answer should be very brief. -0.89. What is the difference between the Expenditure(as % of GDP) of Japan in 2006 and the Expenditure(as % of GDP) of Suriname in 2007?
Provide a succinct answer. 2.27. What is the difference between the Expenditure(as % of GDP) of Japan in 2006 and the Expenditure(as % of GDP) of Syrian Arab Republic in 2007?
Provide a short and direct response. 4.41. What is the difference between the Expenditure(as % of GDP) in Suriname in 2006 and the Expenditure(as % of GDP) in Syrian Arab Republic in 2007?
Keep it short and to the point. 2.42. What is the difference between the Expenditure(as % of GDP) in Indonesia in 2006 and the Expenditure(as % of GDP) in Japan in 2008?
Your answer should be very brief. -5.7. What is the difference between the Expenditure(as % of GDP) in Indonesia in 2006 and the Expenditure(as % of GDP) in Suriname in 2008?
Your answer should be compact. -3.02. What is the difference between the Expenditure(as % of GDP) of Indonesia in 2006 and the Expenditure(as % of GDP) of Syrian Arab Republic in 2008?
Offer a very short reply. -0.46. What is the difference between the Expenditure(as % of GDP) in Japan in 2006 and the Expenditure(as % of GDP) in Suriname in 2008?
Offer a very short reply. 2.28. What is the difference between the Expenditure(as % of GDP) in Japan in 2006 and the Expenditure(as % of GDP) in Syrian Arab Republic in 2008?
Provide a succinct answer. 4.83. What is the difference between the Expenditure(as % of GDP) in Suriname in 2006 and the Expenditure(as % of GDP) in Syrian Arab Republic in 2008?
Make the answer very short. 2.85. What is the difference between the Expenditure(as % of GDP) in Indonesia in 2007 and the Expenditure(as % of GDP) in Japan in 2008?
Provide a short and direct response. -5.51. What is the difference between the Expenditure(as % of GDP) of Indonesia in 2007 and the Expenditure(as % of GDP) of Suriname in 2008?
Offer a terse response. -2.82. What is the difference between the Expenditure(as % of GDP) of Indonesia in 2007 and the Expenditure(as % of GDP) of Syrian Arab Republic in 2008?
Make the answer very short. -0.27. What is the difference between the Expenditure(as % of GDP) in Japan in 2007 and the Expenditure(as % of GDP) in Suriname in 2008?
Your answer should be compact. 2.31. What is the difference between the Expenditure(as % of GDP) in Japan in 2007 and the Expenditure(as % of GDP) in Syrian Arab Republic in 2008?
Give a very brief answer. 4.86. What is the difference between the Expenditure(as % of GDP) of Suriname in 2007 and the Expenditure(as % of GDP) of Syrian Arab Republic in 2008?
Provide a succinct answer. 2.56. What is the average Expenditure(as % of GDP) of Indonesia per year?
Your response must be concise. 2.62. What is the average Expenditure(as % of GDP) in Japan per year?
Offer a terse response. 8.11. What is the average Expenditure(as % of GDP) of Suriname per year?
Make the answer very short. 6.73. What is the average Expenditure(as % of GDP) of Syrian Arab Republic per year?
Keep it short and to the point. 4.31. In the year 2001, what is the difference between the Expenditure(as % of GDP) in Indonesia and Expenditure(as % of GDP) in Japan?
Make the answer very short. -5.57. In the year 2001, what is the difference between the Expenditure(as % of GDP) in Indonesia and Expenditure(as % of GDP) in Suriname?
Provide a succinct answer. -6.16. In the year 2001, what is the difference between the Expenditure(as % of GDP) in Indonesia and Expenditure(as % of GDP) in Syrian Arab Republic?
Your answer should be compact. -2.68. In the year 2001, what is the difference between the Expenditure(as % of GDP) of Japan and Expenditure(as % of GDP) of Suriname?
Offer a very short reply. -0.59. In the year 2001, what is the difference between the Expenditure(as % of GDP) in Japan and Expenditure(as % of GDP) in Syrian Arab Republic?
Your answer should be very brief. 2.89. In the year 2001, what is the difference between the Expenditure(as % of GDP) in Suriname and Expenditure(as % of GDP) in Syrian Arab Republic?
Provide a succinct answer. 3.48. In the year 2002, what is the difference between the Expenditure(as % of GDP) in Indonesia and Expenditure(as % of GDP) in Japan?
Your response must be concise. -5.62. In the year 2002, what is the difference between the Expenditure(as % of GDP) of Indonesia and Expenditure(as % of GDP) of Suriname?
Give a very brief answer. -4.91. In the year 2002, what is the difference between the Expenditure(as % of GDP) of Indonesia and Expenditure(as % of GDP) of Syrian Arab Republic?
Provide a succinct answer. -2.71. In the year 2002, what is the difference between the Expenditure(as % of GDP) of Japan and Expenditure(as % of GDP) of Suriname?
Your response must be concise. 0.72. In the year 2002, what is the difference between the Expenditure(as % of GDP) in Japan and Expenditure(as % of GDP) in Syrian Arab Republic?
Keep it short and to the point. 2.92. In the year 2002, what is the difference between the Expenditure(as % of GDP) of Suriname and Expenditure(as % of GDP) of Syrian Arab Republic?
Your answer should be compact. 2.2. In the year 2003, what is the difference between the Expenditure(as % of GDP) of Indonesia and Expenditure(as % of GDP) of Japan?
Keep it short and to the point. -5.45. In the year 2003, what is the difference between the Expenditure(as % of GDP) in Indonesia and Expenditure(as % of GDP) in Suriname?
Provide a succinct answer. -4.09. In the year 2003, what is the difference between the Expenditure(as % of GDP) of Indonesia and Expenditure(as % of GDP) of Syrian Arab Republic?
Provide a short and direct response. -2.58. In the year 2003, what is the difference between the Expenditure(as % of GDP) in Japan and Expenditure(as % of GDP) in Suriname?
Offer a terse response. 1.36. In the year 2003, what is the difference between the Expenditure(as % of GDP) of Japan and Expenditure(as % of GDP) of Syrian Arab Republic?
Your answer should be very brief. 2.87. In the year 2003, what is the difference between the Expenditure(as % of GDP) in Suriname and Expenditure(as % of GDP) in Syrian Arab Republic?
Provide a succinct answer. 1.51. In the year 2004, what is the difference between the Expenditure(as % of GDP) in Indonesia and Expenditure(as % of GDP) in Japan?
Offer a very short reply. -5.63. In the year 2004, what is the difference between the Expenditure(as % of GDP) in Indonesia and Expenditure(as % of GDP) in Suriname?
Your answer should be very brief. -4.51. In the year 2004, what is the difference between the Expenditure(as % of GDP) in Indonesia and Expenditure(as % of GDP) in Syrian Arab Republic?
Provide a short and direct response. -2.11. In the year 2004, what is the difference between the Expenditure(as % of GDP) of Japan and Expenditure(as % of GDP) of Suriname?
Provide a short and direct response. 1.12. In the year 2004, what is the difference between the Expenditure(as % of GDP) of Japan and Expenditure(as % of GDP) of Syrian Arab Republic?
Give a very brief answer. 3.52. In the year 2004, what is the difference between the Expenditure(as % of GDP) of Suriname and Expenditure(as % of GDP) of Syrian Arab Republic?
Your response must be concise. 2.4. In the year 2005, what is the difference between the Expenditure(as % of GDP) of Indonesia and Expenditure(as % of GDP) of Japan?
Your answer should be compact. -5.39. In the year 2005, what is the difference between the Expenditure(as % of GDP) of Indonesia and Expenditure(as % of GDP) of Suriname?
Keep it short and to the point. -3.99. In the year 2005, what is the difference between the Expenditure(as % of GDP) of Indonesia and Expenditure(as % of GDP) of Syrian Arab Republic?
Ensure brevity in your answer.  -1.32. In the year 2005, what is the difference between the Expenditure(as % of GDP) in Japan and Expenditure(as % of GDP) in Suriname?
Keep it short and to the point. 1.41. In the year 2005, what is the difference between the Expenditure(as % of GDP) of Japan and Expenditure(as % of GDP) of Syrian Arab Republic?
Offer a very short reply. 4.07. In the year 2005, what is the difference between the Expenditure(as % of GDP) in Suriname and Expenditure(as % of GDP) in Syrian Arab Republic?
Provide a succinct answer. 2.67. In the year 2006, what is the difference between the Expenditure(as % of GDP) in Indonesia and Expenditure(as % of GDP) in Japan?
Give a very brief answer. -5.29. In the year 2006, what is the difference between the Expenditure(as % of GDP) of Indonesia and Expenditure(as % of GDP) of Suriname?
Offer a very short reply. -3.31. In the year 2006, what is the difference between the Expenditure(as % of GDP) of Indonesia and Expenditure(as % of GDP) of Syrian Arab Republic?
Provide a succinct answer. -0.87. In the year 2006, what is the difference between the Expenditure(as % of GDP) in Japan and Expenditure(as % of GDP) in Suriname?
Keep it short and to the point. 1.98. In the year 2006, what is the difference between the Expenditure(as % of GDP) in Japan and Expenditure(as % of GDP) in Syrian Arab Republic?
Ensure brevity in your answer.  4.42. In the year 2006, what is the difference between the Expenditure(as % of GDP) in Suriname and Expenditure(as % of GDP) in Syrian Arab Republic?
Ensure brevity in your answer.  2.44. In the year 2007, what is the difference between the Expenditure(as % of GDP) of Indonesia and Expenditure(as % of GDP) of Japan?
Make the answer very short. -5.13. In the year 2007, what is the difference between the Expenditure(as % of GDP) in Indonesia and Expenditure(as % of GDP) in Suriname?
Your answer should be compact. -2.83. In the year 2007, what is the difference between the Expenditure(as % of GDP) in Indonesia and Expenditure(as % of GDP) in Syrian Arab Republic?
Your answer should be very brief. -0.69. In the year 2007, what is the difference between the Expenditure(as % of GDP) of Japan and Expenditure(as % of GDP) of Suriname?
Ensure brevity in your answer.  2.31. In the year 2007, what is the difference between the Expenditure(as % of GDP) in Japan and Expenditure(as % of GDP) in Syrian Arab Republic?
Provide a short and direct response. 4.44. In the year 2007, what is the difference between the Expenditure(as % of GDP) of Suriname and Expenditure(as % of GDP) of Syrian Arab Republic?
Ensure brevity in your answer.  2.13. In the year 2008, what is the difference between the Expenditure(as % of GDP) in Indonesia and Expenditure(as % of GDP) in Japan?
Give a very brief answer. -5.8. In the year 2008, what is the difference between the Expenditure(as % of GDP) of Indonesia and Expenditure(as % of GDP) of Suriname?
Offer a very short reply. -3.12. In the year 2008, what is the difference between the Expenditure(as % of GDP) of Indonesia and Expenditure(as % of GDP) of Syrian Arab Republic?
Give a very brief answer. -0.56. In the year 2008, what is the difference between the Expenditure(as % of GDP) of Japan and Expenditure(as % of GDP) of Suriname?
Offer a terse response. 2.68. In the year 2008, what is the difference between the Expenditure(as % of GDP) in Japan and Expenditure(as % of GDP) in Syrian Arab Republic?
Your answer should be compact. 5.24. In the year 2008, what is the difference between the Expenditure(as % of GDP) in Suriname and Expenditure(as % of GDP) in Syrian Arab Republic?
Provide a short and direct response. 2.55. What is the ratio of the Expenditure(as % of GDP) of Japan in 2001 to that in 2002?
Keep it short and to the point. 0.99. What is the ratio of the Expenditure(as % of GDP) in Suriname in 2001 to that in 2002?
Your answer should be compact. 1.18. What is the ratio of the Expenditure(as % of GDP) in Indonesia in 2001 to that in 2003?
Provide a short and direct response. 0.88. What is the ratio of the Expenditure(as % of GDP) of Japan in 2001 to that in 2003?
Your answer should be very brief. 0.98. What is the ratio of the Expenditure(as % of GDP) of Suriname in 2001 to that in 2003?
Keep it short and to the point. 1.27. What is the ratio of the Expenditure(as % of GDP) in Syrian Arab Republic in 2001 to that in 2003?
Keep it short and to the point. 0.96. What is the ratio of the Expenditure(as % of GDP) in Indonesia in 2001 to that in 2004?
Offer a terse response. 0.94. What is the ratio of the Expenditure(as % of GDP) in Japan in 2001 to that in 2004?
Make the answer very short. 0.98. What is the ratio of the Expenditure(as % of GDP) in Suriname in 2001 to that in 2004?
Provide a short and direct response. 1.22. What is the ratio of the Expenditure(as % of GDP) of Syrian Arab Republic in 2001 to that in 2004?
Offer a terse response. 1.1. What is the ratio of the Expenditure(as % of GDP) in Indonesia in 2001 to that in 2005?
Provide a short and direct response. 0.8. What is the ratio of the Expenditure(as % of GDP) of Japan in 2001 to that in 2005?
Your answer should be compact. 0.95. What is the ratio of the Expenditure(as % of GDP) in Suriname in 2001 to that in 2005?
Make the answer very short. 1.24. What is the ratio of the Expenditure(as % of GDP) of Syrian Arab Republic in 2001 to that in 2005?
Your response must be concise. 1.2. What is the ratio of the Expenditure(as % of GDP) in Indonesia in 2001 to that in 2006?
Give a very brief answer. 0.77. What is the ratio of the Expenditure(as % of GDP) in Japan in 2001 to that in 2006?
Offer a very short reply. 0.95. What is the ratio of the Expenditure(as % of GDP) in Suriname in 2001 to that in 2006?
Make the answer very short. 1.35. What is the ratio of the Expenditure(as % of GDP) in Syrian Arab Republic in 2001 to that in 2006?
Offer a terse response. 1.3. What is the ratio of the Expenditure(as % of GDP) in Indonesia in 2001 to that in 2007?
Give a very brief answer. 0.72. What is the ratio of the Expenditure(as % of GDP) of Japan in 2001 to that in 2007?
Offer a very short reply. 0.95. What is the ratio of the Expenditure(as % of GDP) of Suriname in 2001 to that in 2007?
Ensure brevity in your answer.  1.42. What is the ratio of the Expenditure(as % of GDP) of Syrian Arab Republic in 2001 to that in 2007?
Offer a terse response. 1.3. What is the ratio of the Expenditure(as % of GDP) of Indonesia in 2001 to that in 2008?
Your answer should be compact. 0.8. What is the ratio of the Expenditure(as % of GDP) in Japan in 2001 to that in 2008?
Make the answer very short. 0.91. What is the ratio of the Expenditure(as % of GDP) of Suriname in 2001 to that in 2008?
Offer a terse response. 1.42. What is the ratio of the Expenditure(as % of GDP) in Syrian Arab Republic in 2001 to that in 2008?
Your answer should be very brief. 1.46. What is the ratio of the Expenditure(as % of GDP) in Indonesia in 2002 to that in 2003?
Ensure brevity in your answer.  0.88. What is the ratio of the Expenditure(as % of GDP) of Japan in 2002 to that in 2003?
Give a very brief answer. 0.98. What is the ratio of the Expenditure(as % of GDP) of Suriname in 2002 to that in 2003?
Your response must be concise. 1.08. What is the ratio of the Expenditure(as % of GDP) of Syrian Arab Republic in 2002 to that in 2003?
Keep it short and to the point. 0.97. What is the ratio of the Expenditure(as % of GDP) of Indonesia in 2002 to that in 2004?
Your response must be concise. 0.94. What is the ratio of the Expenditure(as % of GDP) in Japan in 2002 to that in 2004?
Your answer should be compact. 0.98. What is the ratio of the Expenditure(as % of GDP) in Suriname in 2002 to that in 2004?
Keep it short and to the point. 1.04. What is the ratio of the Expenditure(as % of GDP) of Syrian Arab Republic in 2002 to that in 2004?
Your response must be concise. 1.1. What is the ratio of the Expenditure(as % of GDP) in Indonesia in 2002 to that in 2005?
Ensure brevity in your answer.  0.8. What is the ratio of the Expenditure(as % of GDP) in Japan in 2002 to that in 2005?
Give a very brief answer. 0.96. What is the ratio of the Expenditure(as % of GDP) of Suriname in 2002 to that in 2005?
Offer a very short reply. 1.05. What is the ratio of the Expenditure(as % of GDP) in Syrian Arab Republic in 2002 to that in 2005?
Ensure brevity in your answer.  1.2. What is the ratio of the Expenditure(as % of GDP) of Indonesia in 2002 to that in 2006?
Your answer should be compact. 0.77. What is the ratio of the Expenditure(as % of GDP) of Japan in 2002 to that in 2006?
Your response must be concise. 0.96. What is the ratio of the Expenditure(as % of GDP) of Suriname in 2002 to that in 2006?
Your answer should be compact. 1.15. What is the ratio of the Expenditure(as % of GDP) of Syrian Arab Republic in 2002 to that in 2006?
Give a very brief answer. 1.31. What is the ratio of the Expenditure(as % of GDP) of Indonesia in 2002 to that in 2007?
Your response must be concise. 0.72. What is the ratio of the Expenditure(as % of GDP) in Japan in 2002 to that in 2007?
Your response must be concise. 0.95. What is the ratio of the Expenditure(as % of GDP) of Suriname in 2002 to that in 2007?
Keep it short and to the point. 1.21. What is the ratio of the Expenditure(as % of GDP) in Syrian Arab Republic in 2002 to that in 2007?
Your response must be concise. 1.3. What is the ratio of the Expenditure(as % of GDP) in Indonesia in 2002 to that in 2008?
Give a very brief answer. 0.8. What is the ratio of the Expenditure(as % of GDP) of Japan in 2002 to that in 2008?
Offer a very short reply. 0.91. What is the ratio of the Expenditure(as % of GDP) of Suriname in 2002 to that in 2008?
Your response must be concise. 1.21. What is the ratio of the Expenditure(as % of GDP) in Syrian Arab Republic in 2002 to that in 2008?
Keep it short and to the point. 1.47. What is the ratio of the Expenditure(as % of GDP) in Indonesia in 2003 to that in 2004?
Provide a short and direct response. 1.07. What is the ratio of the Expenditure(as % of GDP) of Japan in 2003 to that in 2004?
Give a very brief answer. 1. What is the ratio of the Expenditure(as % of GDP) of Suriname in 2003 to that in 2004?
Offer a very short reply. 0.96. What is the ratio of the Expenditure(as % of GDP) of Syrian Arab Republic in 2003 to that in 2004?
Ensure brevity in your answer.  1.14. What is the ratio of the Expenditure(as % of GDP) of Indonesia in 2003 to that in 2005?
Make the answer very short. 0.91. What is the ratio of the Expenditure(as % of GDP) in Japan in 2003 to that in 2005?
Keep it short and to the point. 0.98. What is the ratio of the Expenditure(as % of GDP) of Suriname in 2003 to that in 2005?
Give a very brief answer. 0.98. What is the ratio of the Expenditure(as % of GDP) of Syrian Arab Republic in 2003 to that in 2005?
Your answer should be compact. 1.24. What is the ratio of the Expenditure(as % of GDP) of Indonesia in 2003 to that in 2006?
Provide a succinct answer. 0.87. What is the ratio of the Expenditure(as % of GDP) of Japan in 2003 to that in 2006?
Provide a succinct answer. 0.97. What is the ratio of the Expenditure(as % of GDP) of Suriname in 2003 to that in 2006?
Your response must be concise. 1.07. What is the ratio of the Expenditure(as % of GDP) in Syrian Arab Republic in 2003 to that in 2006?
Make the answer very short. 1.35. What is the ratio of the Expenditure(as % of GDP) in Indonesia in 2003 to that in 2007?
Your answer should be compact. 0.82. What is the ratio of the Expenditure(as % of GDP) in Japan in 2003 to that in 2007?
Make the answer very short. 0.97. What is the ratio of the Expenditure(as % of GDP) of Suriname in 2003 to that in 2007?
Offer a terse response. 1.12. What is the ratio of the Expenditure(as % of GDP) of Syrian Arab Republic in 2003 to that in 2007?
Offer a very short reply. 1.35. What is the ratio of the Expenditure(as % of GDP) in Indonesia in 2003 to that in 2008?
Offer a very short reply. 0.9. What is the ratio of the Expenditure(as % of GDP) in Japan in 2003 to that in 2008?
Provide a short and direct response. 0.93. What is the ratio of the Expenditure(as % of GDP) in Suriname in 2003 to that in 2008?
Offer a very short reply. 1.12. What is the ratio of the Expenditure(as % of GDP) in Syrian Arab Republic in 2003 to that in 2008?
Give a very brief answer. 1.52. What is the ratio of the Expenditure(as % of GDP) of Indonesia in 2004 to that in 2005?
Provide a succinct answer. 0.85. What is the ratio of the Expenditure(as % of GDP) of Japan in 2004 to that in 2005?
Your answer should be very brief. 0.98. What is the ratio of the Expenditure(as % of GDP) in Suriname in 2004 to that in 2005?
Your response must be concise. 1.01. What is the ratio of the Expenditure(as % of GDP) of Syrian Arab Republic in 2004 to that in 2005?
Provide a succinct answer. 1.09. What is the ratio of the Expenditure(as % of GDP) in Indonesia in 2004 to that in 2006?
Your response must be concise. 0.81. What is the ratio of the Expenditure(as % of GDP) in Japan in 2004 to that in 2006?
Give a very brief answer. 0.98. What is the ratio of the Expenditure(as % of GDP) of Suriname in 2004 to that in 2006?
Ensure brevity in your answer.  1.11. What is the ratio of the Expenditure(as % of GDP) in Syrian Arab Republic in 2004 to that in 2006?
Keep it short and to the point. 1.19. What is the ratio of the Expenditure(as % of GDP) of Indonesia in 2004 to that in 2007?
Your answer should be very brief. 0.76. What is the ratio of the Expenditure(as % of GDP) in Japan in 2004 to that in 2007?
Offer a very short reply. 0.97. What is the ratio of the Expenditure(as % of GDP) of Suriname in 2004 to that in 2007?
Your response must be concise. 1.16. What is the ratio of the Expenditure(as % of GDP) of Syrian Arab Republic in 2004 to that in 2007?
Give a very brief answer. 1.18. What is the ratio of the Expenditure(as % of GDP) of Indonesia in 2004 to that in 2008?
Ensure brevity in your answer.  0.84. What is the ratio of the Expenditure(as % of GDP) in Japan in 2004 to that in 2008?
Offer a terse response. 0.93. What is the ratio of the Expenditure(as % of GDP) in Suriname in 2004 to that in 2008?
Provide a succinct answer. 1.16. What is the ratio of the Expenditure(as % of GDP) of Syrian Arab Republic in 2004 to that in 2008?
Provide a succinct answer. 1.33. What is the ratio of the Expenditure(as % of GDP) in Indonesia in 2005 to that in 2006?
Give a very brief answer. 0.96. What is the ratio of the Expenditure(as % of GDP) in Suriname in 2005 to that in 2006?
Your response must be concise. 1.09. What is the ratio of the Expenditure(as % of GDP) in Syrian Arab Republic in 2005 to that in 2006?
Offer a very short reply. 1.09. What is the ratio of the Expenditure(as % of GDP) of Indonesia in 2005 to that in 2007?
Offer a very short reply. 0.9. What is the ratio of the Expenditure(as % of GDP) of Suriname in 2005 to that in 2007?
Keep it short and to the point. 1.14. What is the ratio of the Expenditure(as % of GDP) in Syrian Arab Republic in 2005 to that in 2007?
Offer a terse response. 1.08. What is the ratio of the Expenditure(as % of GDP) in Japan in 2005 to that in 2008?
Your response must be concise. 0.95. What is the ratio of the Expenditure(as % of GDP) in Suriname in 2005 to that in 2008?
Make the answer very short. 1.14. What is the ratio of the Expenditure(as % of GDP) of Syrian Arab Republic in 2005 to that in 2008?
Provide a short and direct response. 1.22. What is the ratio of the Expenditure(as % of GDP) in Indonesia in 2006 to that in 2007?
Offer a terse response. 0.94. What is the ratio of the Expenditure(as % of GDP) in Suriname in 2006 to that in 2007?
Your response must be concise. 1.05. What is the ratio of the Expenditure(as % of GDP) of Syrian Arab Republic in 2006 to that in 2007?
Keep it short and to the point. 1. What is the ratio of the Expenditure(as % of GDP) of Indonesia in 2006 to that in 2008?
Keep it short and to the point. 1.04. What is the ratio of the Expenditure(as % of GDP) of Japan in 2006 to that in 2008?
Offer a very short reply. 0.95. What is the ratio of the Expenditure(as % of GDP) in Suriname in 2006 to that in 2008?
Offer a terse response. 1.05. What is the ratio of the Expenditure(as % of GDP) of Syrian Arab Republic in 2006 to that in 2008?
Make the answer very short. 1.12. What is the ratio of the Expenditure(as % of GDP) of Indonesia in 2007 to that in 2008?
Keep it short and to the point. 1.1. What is the ratio of the Expenditure(as % of GDP) of Japan in 2007 to that in 2008?
Offer a terse response. 0.96. What is the ratio of the Expenditure(as % of GDP) of Suriname in 2007 to that in 2008?
Provide a short and direct response. 1. What is the ratio of the Expenditure(as % of GDP) of Syrian Arab Republic in 2007 to that in 2008?
Make the answer very short. 1.13. What is the difference between the highest and the second highest Expenditure(as % of GDP) of Indonesia?
Your answer should be very brief. 0.19. What is the difference between the highest and the second highest Expenditure(as % of GDP) in Japan?
Make the answer very short. 0.38. What is the difference between the highest and the second highest Expenditure(as % of GDP) of Suriname?
Your answer should be very brief. 1.25. What is the difference between the highest and the second highest Expenditure(as % of GDP) in Syrian Arab Republic?
Provide a short and direct response. 0.17. What is the difference between the highest and the lowest Expenditure(as % of GDP) of Indonesia?
Provide a short and direct response. 0.87. What is the difference between the highest and the lowest Expenditure(as % of GDP) in Japan?
Your response must be concise. 0.8. What is the difference between the highest and the lowest Expenditure(as % of GDP) of Suriname?
Your answer should be compact. 2.47. What is the difference between the highest and the lowest Expenditure(as % of GDP) in Syrian Arab Republic?
Your response must be concise. 1.75. 